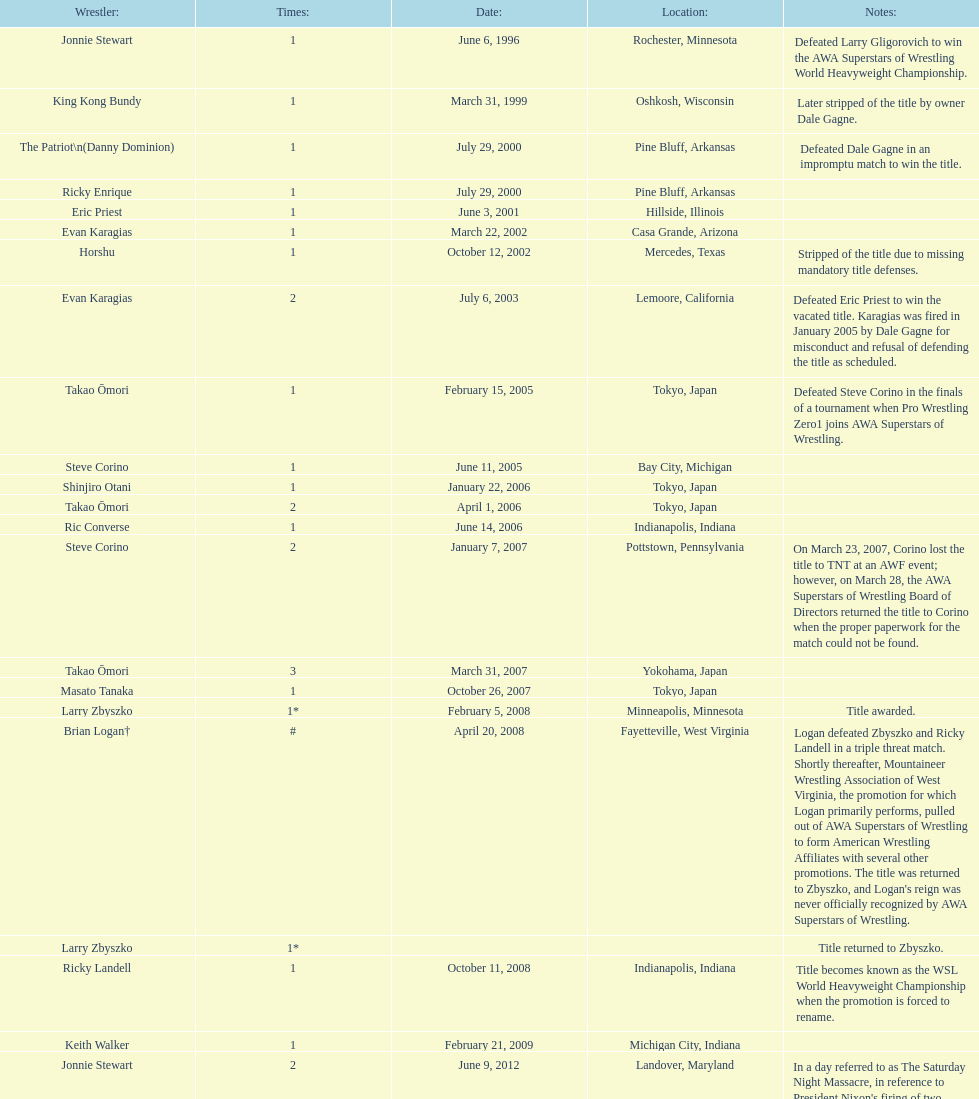Who is the final wrestler to have the title? The Honky Tonk Man. 